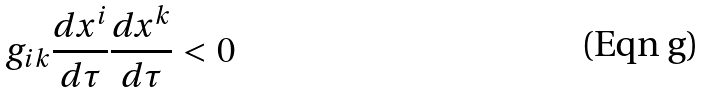Convert formula to latex. <formula><loc_0><loc_0><loc_500><loc_500>g _ { i k } \frac { d x ^ { i } } { d \tau } \frac { d x ^ { k } } { d \tau } < 0</formula> 